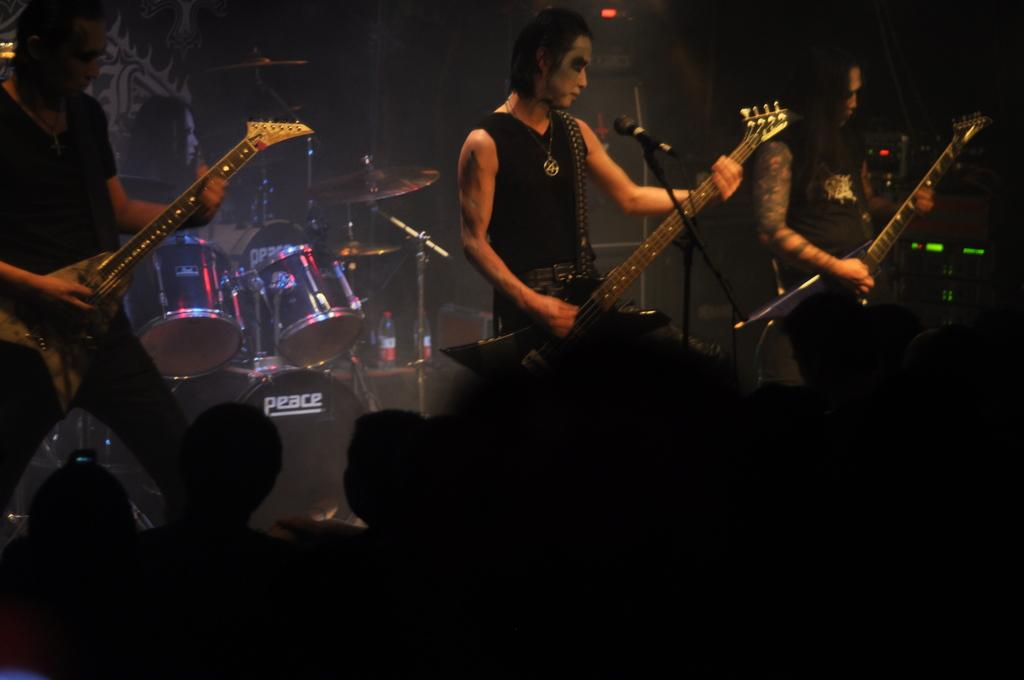What are the people in the image holding? The people in the image are holding guitars. What musical instrument can be seen in the background of the image? There is a drum set in the background of the image. Are there any other people visible in the image besides those holding guitars? Yes, there is at least one more person in the background of the image. What type of leather is being used to make the guitar strings in the image? There is no information about the guitar strings or the type of leather used in the image. 